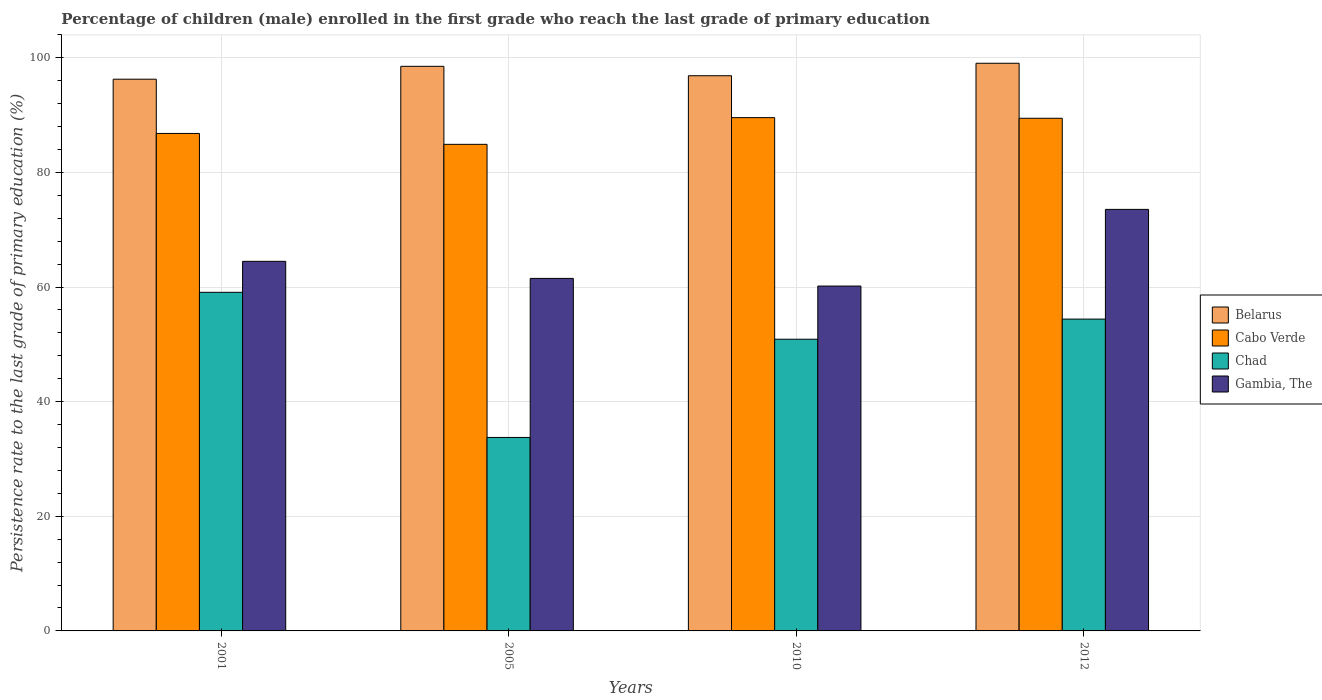How many different coloured bars are there?
Keep it short and to the point. 4. How many bars are there on the 2nd tick from the left?
Your response must be concise. 4. What is the persistence rate of children in Chad in 2005?
Your answer should be very brief. 33.76. Across all years, what is the maximum persistence rate of children in Chad?
Your response must be concise. 59.08. Across all years, what is the minimum persistence rate of children in Cabo Verde?
Provide a succinct answer. 84.91. In which year was the persistence rate of children in Gambia, The minimum?
Provide a succinct answer. 2010. What is the total persistence rate of children in Cabo Verde in the graph?
Make the answer very short. 350.73. What is the difference between the persistence rate of children in Chad in 2005 and that in 2010?
Offer a terse response. -17.14. What is the difference between the persistence rate of children in Chad in 2005 and the persistence rate of children in Cabo Verde in 2012?
Ensure brevity in your answer.  -55.69. What is the average persistence rate of children in Chad per year?
Provide a succinct answer. 49.54. In the year 2001, what is the difference between the persistence rate of children in Chad and persistence rate of children in Cabo Verde?
Provide a short and direct response. -27.72. In how many years, is the persistence rate of children in Gambia, The greater than 36 %?
Your answer should be very brief. 4. What is the ratio of the persistence rate of children in Belarus in 2005 to that in 2010?
Keep it short and to the point. 1.02. Is the persistence rate of children in Chad in 2005 less than that in 2012?
Offer a terse response. Yes. Is the difference between the persistence rate of children in Chad in 2010 and 2012 greater than the difference between the persistence rate of children in Cabo Verde in 2010 and 2012?
Give a very brief answer. No. What is the difference between the highest and the second highest persistence rate of children in Belarus?
Keep it short and to the point. 0.54. What is the difference between the highest and the lowest persistence rate of children in Belarus?
Your response must be concise. 2.78. In how many years, is the persistence rate of children in Gambia, The greater than the average persistence rate of children in Gambia, The taken over all years?
Offer a terse response. 1. Is the sum of the persistence rate of children in Chad in 2010 and 2012 greater than the maximum persistence rate of children in Belarus across all years?
Your response must be concise. Yes. What does the 1st bar from the left in 2001 represents?
Offer a terse response. Belarus. What does the 2nd bar from the right in 2001 represents?
Your answer should be compact. Chad. Is it the case that in every year, the sum of the persistence rate of children in Belarus and persistence rate of children in Cabo Verde is greater than the persistence rate of children in Chad?
Provide a succinct answer. Yes. How many bars are there?
Make the answer very short. 16. How many years are there in the graph?
Your answer should be compact. 4. Does the graph contain any zero values?
Offer a terse response. No. Does the graph contain grids?
Your answer should be very brief. Yes. How many legend labels are there?
Keep it short and to the point. 4. How are the legend labels stacked?
Offer a terse response. Vertical. What is the title of the graph?
Offer a terse response. Percentage of children (male) enrolled in the first grade who reach the last grade of primary education. Does "French Polynesia" appear as one of the legend labels in the graph?
Provide a short and direct response. No. What is the label or title of the X-axis?
Provide a succinct answer. Years. What is the label or title of the Y-axis?
Your answer should be very brief. Persistence rate to the last grade of primary education (%). What is the Persistence rate to the last grade of primary education (%) of Belarus in 2001?
Ensure brevity in your answer.  96.27. What is the Persistence rate to the last grade of primary education (%) of Cabo Verde in 2001?
Make the answer very short. 86.81. What is the Persistence rate to the last grade of primary education (%) of Chad in 2001?
Make the answer very short. 59.08. What is the Persistence rate to the last grade of primary education (%) of Gambia, The in 2001?
Provide a short and direct response. 64.49. What is the Persistence rate to the last grade of primary education (%) in Belarus in 2005?
Give a very brief answer. 98.52. What is the Persistence rate to the last grade of primary education (%) of Cabo Verde in 2005?
Your response must be concise. 84.91. What is the Persistence rate to the last grade of primary education (%) in Chad in 2005?
Your response must be concise. 33.76. What is the Persistence rate to the last grade of primary education (%) in Gambia, The in 2005?
Ensure brevity in your answer.  61.51. What is the Persistence rate to the last grade of primary education (%) of Belarus in 2010?
Ensure brevity in your answer.  96.88. What is the Persistence rate to the last grade of primary education (%) of Cabo Verde in 2010?
Make the answer very short. 89.57. What is the Persistence rate to the last grade of primary education (%) of Chad in 2010?
Your response must be concise. 50.9. What is the Persistence rate to the last grade of primary education (%) in Gambia, The in 2010?
Offer a very short reply. 60.18. What is the Persistence rate to the last grade of primary education (%) of Belarus in 2012?
Offer a very short reply. 99.05. What is the Persistence rate to the last grade of primary education (%) in Cabo Verde in 2012?
Your answer should be compact. 89.45. What is the Persistence rate to the last grade of primary education (%) in Chad in 2012?
Your answer should be very brief. 54.41. What is the Persistence rate to the last grade of primary education (%) in Gambia, The in 2012?
Your answer should be very brief. 73.56. Across all years, what is the maximum Persistence rate to the last grade of primary education (%) in Belarus?
Keep it short and to the point. 99.05. Across all years, what is the maximum Persistence rate to the last grade of primary education (%) in Cabo Verde?
Your response must be concise. 89.57. Across all years, what is the maximum Persistence rate to the last grade of primary education (%) of Chad?
Provide a succinct answer. 59.08. Across all years, what is the maximum Persistence rate to the last grade of primary education (%) of Gambia, The?
Your answer should be very brief. 73.56. Across all years, what is the minimum Persistence rate to the last grade of primary education (%) in Belarus?
Offer a terse response. 96.27. Across all years, what is the minimum Persistence rate to the last grade of primary education (%) of Cabo Verde?
Ensure brevity in your answer.  84.91. Across all years, what is the minimum Persistence rate to the last grade of primary education (%) in Chad?
Provide a succinct answer. 33.76. Across all years, what is the minimum Persistence rate to the last grade of primary education (%) in Gambia, The?
Give a very brief answer. 60.18. What is the total Persistence rate to the last grade of primary education (%) of Belarus in the graph?
Provide a short and direct response. 390.72. What is the total Persistence rate to the last grade of primary education (%) of Cabo Verde in the graph?
Give a very brief answer. 350.73. What is the total Persistence rate to the last grade of primary education (%) in Chad in the graph?
Give a very brief answer. 198.15. What is the total Persistence rate to the last grade of primary education (%) in Gambia, The in the graph?
Your answer should be compact. 259.74. What is the difference between the Persistence rate to the last grade of primary education (%) of Belarus in 2001 and that in 2005?
Your answer should be very brief. -2.25. What is the difference between the Persistence rate to the last grade of primary education (%) in Cabo Verde in 2001 and that in 2005?
Offer a terse response. 1.9. What is the difference between the Persistence rate to the last grade of primary education (%) in Chad in 2001 and that in 2005?
Make the answer very short. 25.32. What is the difference between the Persistence rate to the last grade of primary education (%) in Gambia, The in 2001 and that in 2005?
Provide a succinct answer. 2.98. What is the difference between the Persistence rate to the last grade of primary education (%) of Belarus in 2001 and that in 2010?
Keep it short and to the point. -0.61. What is the difference between the Persistence rate to the last grade of primary education (%) of Cabo Verde in 2001 and that in 2010?
Offer a very short reply. -2.76. What is the difference between the Persistence rate to the last grade of primary education (%) of Chad in 2001 and that in 2010?
Ensure brevity in your answer.  8.19. What is the difference between the Persistence rate to the last grade of primary education (%) in Gambia, The in 2001 and that in 2010?
Provide a succinct answer. 4.31. What is the difference between the Persistence rate to the last grade of primary education (%) in Belarus in 2001 and that in 2012?
Give a very brief answer. -2.78. What is the difference between the Persistence rate to the last grade of primary education (%) in Cabo Verde in 2001 and that in 2012?
Make the answer very short. -2.65. What is the difference between the Persistence rate to the last grade of primary education (%) of Chad in 2001 and that in 2012?
Keep it short and to the point. 4.67. What is the difference between the Persistence rate to the last grade of primary education (%) in Gambia, The in 2001 and that in 2012?
Give a very brief answer. -9.07. What is the difference between the Persistence rate to the last grade of primary education (%) of Belarus in 2005 and that in 2010?
Make the answer very short. 1.64. What is the difference between the Persistence rate to the last grade of primary education (%) of Cabo Verde in 2005 and that in 2010?
Offer a terse response. -4.66. What is the difference between the Persistence rate to the last grade of primary education (%) in Chad in 2005 and that in 2010?
Make the answer very short. -17.14. What is the difference between the Persistence rate to the last grade of primary education (%) in Gambia, The in 2005 and that in 2010?
Your answer should be compact. 1.34. What is the difference between the Persistence rate to the last grade of primary education (%) in Belarus in 2005 and that in 2012?
Provide a short and direct response. -0.54. What is the difference between the Persistence rate to the last grade of primary education (%) of Cabo Verde in 2005 and that in 2012?
Give a very brief answer. -4.55. What is the difference between the Persistence rate to the last grade of primary education (%) of Chad in 2005 and that in 2012?
Provide a short and direct response. -20.65. What is the difference between the Persistence rate to the last grade of primary education (%) of Gambia, The in 2005 and that in 2012?
Offer a terse response. -12.04. What is the difference between the Persistence rate to the last grade of primary education (%) of Belarus in 2010 and that in 2012?
Ensure brevity in your answer.  -2.18. What is the difference between the Persistence rate to the last grade of primary education (%) in Cabo Verde in 2010 and that in 2012?
Provide a succinct answer. 0.11. What is the difference between the Persistence rate to the last grade of primary education (%) in Chad in 2010 and that in 2012?
Ensure brevity in your answer.  -3.51. What is the difference between the Persistence rate to the last grade of primary education (%) of Gambia, The in 2010 and that in 2012?
Your response must be concise. -13.38. What is the difference between the Persistence rate to the last grade of primary education (%) of Belarus in 2001 and the Persistence rate to the last grade of primary education (%) of Cabo Verde in 2005?
Ensure brevity in your answer.  11.37. What is the difference between the Persistence rate to the last grade of primary education (%) of Belarus in 2001 and the Persistence rate to the last grade of primary education (%) of Chad in 2005?
Make the answer very short. 62.51. What is the difference between the Persistence rate to the last grade of primary education (%) of Belarus in 2001 and the Persistence rate to the last grade of primary education (%) of Gambia, The in 2005?
Give a very brief answer. 34.76. What is the difference between the Persistence rate to the last grade of primary education (%) in Cabo Verde in 2001 and the Persistence rate to the last grade of primary education (%) in Chad in 2005?
Keep it short and to the point. 53.04. What is the difference between the Persistence rate to the last grade of primary education (%) of Cabo Verde in 2001 and the Persistence rate to the last grade of primary education (%) of Gambia, The in 2005?
Make the answer very short. 25.29. What is the difference between the Persistence rate to the last grade of primary education (%) in Chad in 2001 and the Persistence rate to the last grade of primary education (%) in Gambia, The in 2005?
Ensure brevity in your answer.  -2.43. What is the difference between the Persistence rate to the last grade of primary education (%) of Belarus in 2001 and the Persistence rate to the last grade of primary education (%) of Cabo Verde in 2010?
Make the answer very short. 6.71. What is the difference between the Persistence rate to the last grade of primary education (%) of Belarus in 2001 and the Persistence rate to the last grade of primary education (%) of Chad in 2010?
Make the answer very short. 45.37. What is the difference between the Persistence rate to the last grade of primary education (%) of Belarus in 2001 and the Persistence rate to the last grade of primary education (%) of Gambia, The in 2010?
Provide a succinct answer. 36.09. What is the difference between the Persistence rate to the last grade of primary education (%) in Cabo Verde in 2001 and the Persistence rate to the last grade of primary education (%) in Chad in 2010?
Provide a succinct answer. 35.91. What is the difference between the Persistence rate to the last grade of primary education (%) in Cabo Verde in 2001 and the Persistence rate to the last grade of primary education (%) in Gambia, The in 2010?
Offer a very short reply. 26.63. What is the difference between the Persistence rate to the last grade of primary education (%) in Chad in 2001 and the Persistence rate to the last grade of primary education (%) in Gambia, The in 2010?
Provide a succinct answer. -1.09. What is the difference between the Persistence rate to the last grade of primary education (%) in Belarus in 2001 and the Persistence rate to the last grade of primary education (%) in Cabo Verde in 2012?
Make the answer very short. 6.82. What is the difference between the Persistence rate to the last grade of primary education (%) in Belarus in 2001 and the Persistence rate to the last grade of primary education (%) in Chad in 2012?
Provide a short and direct response. 41.86. What is the difference between the Persistence rate to the last grade of primary education (%) in Belarus in 2001 and the Persistence rate to the last grade of primary education (%) in Gambia, The in 2012?
Give a very brief answer. 22.72. What is the difference between the Persistence rate to the last grade of primary education (%) in Cabo Verde in 2001 and the Persistence rate to the last grade of primary education (%) in Chad in 2012?
Ensure brevity in your answer.  32.4. What is the difference between the Persistence rate to the last grade of primary education (%) in Cabo Verde in 2001 and the Persistence rate to the last grade of primary education (%) in Gambia, The in 2012?
Provide a short and direct response. 13.25. What is the difference between the Persistence rate to the last grade of primary education (%) of Chad in 2001 and the Persistence rate to the last grade of primary education (%) of Gambia, The in 2012?
Ensure brevity in your answer.  -14.47. What is the difference between the Persistence rate to the last grade of primary education (%) of Belarus in 2005 and the Persistence rate to the last grade of primary education (%) of Cabo Verde in 2010?
Make the answer very short. 8.95. What is the difference between the Persistence rate to the last grade of primary education (%) in Belarus in 2005 and the Persistence rate to the last grade of primary education (%) in Chad in 2010?
Give a very brief answer. 47.62. What is the difference between the Persistence rate to the last grade of primary education (%) of Belarus in 2005 and the Persistence rate to the last grade of primary education (%) of Gambia, The in 2010?
Make the answer very short. 38.34. What is the difference between the Persistence rate to the last grade of primary education (%) of Cabo Verde in 2005 and the Persistence rate to the last grade of primary education (%) of Chad in 2010?
Ensure brevity in your answer.  34.01. What is the difference between the Persistence rate to the last grade of primary education (%) in Cabo Verde in 2005 and the Persistence rate to the last grade of primary education (%) in Gambia, The in 2010?
Offer a very short reply. 24.73. What is the difference between the Persistence rate to the last grade of primary education (%) in Chad in 2005 and the Persistence rate to the last grade of primary education (%) in Gambia, The in 2010?
Your answer should be very brief. -26.42. What is the difference between the Persistence rate to the last grade of primary education (%) of Belarus in 2005 and the Persistence rate to the last grade of primary education (%) of Cabo Verde in 2012?
Your response must be concise. 9.07. What is the difference between the Persistence rate to the last grade of primary education (%) in Belarus in 2005 and the Persistence rate to the last grade of primary education (%) in Chad in 2012?
Offer a very short reply. 44.11. What is the difference between the Persistence rate to the last grade of primary education (%) of Belarus in 2005 and the Persistence rate to the last grade of primary education (%) of Gambia, The in 2012?
Offer a very short reply. 24.96. What is the difference between the Persistence rate to the last grade of primary education (%) of Cabo Verde in 2005 and the Persistence rate to the last grade of primary education (%) of Chad in 2012?
Provide a short and direct response. 30.5. What is the difference between the Persistence rate to the last grade of primary education (%) of Cabo Verde in 2005 and the Persistence rate to the last grade of primary education (%) of Gambia, The in 2012?
Keep it short and to the point. 11.35. What is the difference between the Persistence rate to the last grade of primary education (%) in Chad in 2005 and the Persistence rate to the last grade of primary education (%) in Gambia, The in 2012?
Offer a terse response. -39.8. What is the difference between the Persistence rate to the last grade of primary education (%) of Belarus in 2010 and the Persistence rate to the last grade of primary education (%) of Cabo Verde in 2012?
Give a very brief answer. 7.43. What is the difference between the Persistence rate to the last grade of primary education (%) of Belarus in 2010 and the Persistence rate to the last grade of primary education (%) of Chad in 2012?
Provide a short and direct response. 42.47. What is the difference between the Persistence rate to the last grade of primary education (%) of Belarus in 2010 and the Persistence rate to the last grade of primary education (%) of Gambia, The in 2012?
Make the answer very short. 23.32. What is the difference between the Persistence rate to the last grade of primary education (%) of Cabo Verde in 2010 and the Persistence rate to the last grade of primary education (%) of Chad in 2012?
Offer a very short reply. 35.16. What is the difference between the Persistence rate to the last grade of primary education (%) of Cabo Verde in 2010 and the Persistence rate to the last grade of primary education (%) of Gambia, The in 2012?
Your answer should be compact. 16.01. What is the difference between the Persistence rate to the last grade of primary education (%) in Chad in 2010 and the Persistence rate to the last grade of primary education (%) in Gambia, The in 2012?
Provide a succinct answer. -22.66. What is the average Persistence rate to the last grade of primary education (%) of Belarus per year?
Make the answer very short. 97.68. What is the average Persistence rate to the last grade of primary education (%) of Cabo Verde per year?
Keep it short and to the point. 87.68. What is the average Persistence rate to the last grade of primary education (%) of Chad per year?
Keep it short and to the point. 49.54. What is the average Persistence rate to the last grade of primary education (%) of Gambia, The per year?
Ensure brevity in your answer.  64.93. In the year 2001, what is the difference between the Persistence rate to the last grade of primary education (%) of Belarus and Persistence rate to the last grade of primary education (%) of Cabo Verde?
Your answer should be very brief. 9.47. In the year 2001, what is the difference between the Persistence rate to the last grade of primary education (%) in Belarus and Persistence rate to the last grade of primary education (%) in Chad?
Offer a very short reply. 37.19. In the year 2001, what is the difference between the Persistence rate to the last grade of primary education (%) of Belarus and Persistence rate to the last grade of primary education (%) of Gambia, The?
Provide a short and direct response. 31.78. In the year 2001, what is the difference between the Persistence rate to the last grade of primary education (%) in Cabo Verde and Persistence rate to the last grade of primary education (%) in Chad?
Your answer should be very brief. 27.72. In the year 2001, what is the difference between the Persistence rate to the last grade of primary education (%) of Cabo Verde and Persistence rate to the last grade of primary education (%) of Gambia, The?
Offer a very short reply. 22.31. In the year 2001, what is the difference between the Persistence rate to the last grade of primary education (%) in Chad and Persistence rate to the last grade of primary education (%) in Gambia, The?
Make the answer very short. -5.41. In the year 2005, what is the difference between the Persistence rate to the last grade of primary education (%) in Belarus and Persistence rate to the last grade of primary education (%) in Cabo Verde?
Keep it short and to the point. 13.61. In the year 2005, what is the difference between the Persistence rate to the last grade of primary education (%) of Belarus and Persistence rate to the last grade of primary education (%) of Chad?
Your response must be concise. 64.76. In the year 2005, what is the difference between the Persistence rate to the last grade of primary education (%) of Belarus and Persistence rate to the last grade of primary education (%) of Gambia, The?
Your answer should be very brief. 37. In the year 2005, what is the difference between the Persistence rate to the last grade of primary education (%) in Cabo Verde and Persistence rate to the last grade of primary education (%) in Chad?
Keep it short and to the point. 51.15. In the year 2005, what is the difference between the Persistence rate to the last grade of primary education (%) in Cabo Verde and Persistence rate to the last grade of primary education (%) in Gambia, The?
Provide a short and direct response. 23.39. In the year 2005, what is the difference between the Persistence rate to the last grade of primary education (%) of Chad and Persistence rate to the last grade of primary education (%) of Gambia, The?
Offer a terse response. -27.75. In the year 2010, what is the difference between the Persistence rate to the last grade of primary education (%) in Belarus and Persistence rate to the last grade of primary education (%) in Cabo Verde?
Ensure brevity in your answer.  7.31. In the year 2010, what is the difference between the Persistence rate to the last grade of primary education (%) of Belarus and Persistence rate to the last grade of primary education (%) of Chad?
Offer a very short reply. 45.98. In the year 2010, what is the difference between the Persistence rate to the last grade of primary education (%) in Belarus and Persistence rate to the last grade of primary education (%) in Gambia, The?
Offer a very short reply. 36.7. In the year 2010, what is the difference between the Persistence rate to the last grade of primary education (%) of Cabo Verde and Persistence rate to the last grade of primary education (%) of Chad?
Offer a terse response. 38.67. In the year 2010, what is the difference between the Persistence rate to the last grade of primary education (%) of Cabo Verde and Persistence rate to the last grade of primary education (%) of Gambia, The?
Your response must be concise. 29.39. In the year 2010, what is the difference between the Persistence rate to the last grade of primary education (%) in Chad and Persistence rate to the last grade of primary education (%) in Gambia, The?
Your response must be concise. -9.28. In the year 2012, what is the difference between the Persistence rate to the last grade of primary education (%) of Belarus and Persistence rate to the last grade of primary education (%) of Cabo Verde?
Provide a short and direct response. 9.6. In the year 2012, what is the difference between the Persistence rate to the last grade of primary education (%) of Belarus and Persistence rate to the last grade of primary education (%) of Chad?
Make the answer very short. 44.64. In the year 2012, what is the difference between the Persistence rate to the last grade of primary education (%) of Belarus and Persistence rate to the last grade of primary education (%) of Gambia, The?
Offer a terse response. 25.5. In the year 2012, what is the difference between the Persistence rate to the last grade of primary education (%) in Cabo Verde and Persistence rate to the last grade of primary education (%) in Chad?
Your answer should be very brief. 35.04. In the year 2012, what is the difference between the Persistence rate to the last grade of primary education (%) of Cabo Verde and Persistence rate to the last grade of primary education (%) of Gambia, The?
Offer a very short reply. 15.9. In the year 2012, what is the difference between the Persistence rate to the last grade of primary education (%) in Chad and Persistence rate to the last grade of primary education (%) in Gambia, The?
Give a very brief answer. -19.15. What is the ratio of the Persistence rate to the last grade of primary education (%) of Belarus in 2001 to that in 2005?
Your response must be concise. 0.98. What is the ratio of the Persistence rate to the last grade of primary education (%) of Cabo Verde in 2001 to that in 2005?
Provide a succinct answer. 1.02. What is the ratio of the Persistence rate to the last grade of primary education (%) of Chad in 2001 to that in 2005?
Your answer should be very brief. 1.75. What is the ratio of the Persistence rate to the last grade of primary education (%) in Gambia, The in 2001 to that in 2005?
Your response must be concise. 1.05. What is the ratio of the Persistence rate to the last grade of primary education (%) of Belarus in 2001 to that in 2010?
Your response must be concise. 0.99. What is the ratio of the Persistence rate to the last grade of primary education (%) in Cabo Verde in 2001 to that in 2010?
Offer a terse response. 0.97. What is the ratio of the Persistence rate to the last grade of primary education (%) in Chad in 2001 to that in 2010?
Keep it short and to the point. 1.16. What is the ratio of the Persistence rate to the last grade of primary education (%) in Gambia, The in 2001 to that in 2010?
Offer a very short reply. 1.07. What is the ratio of the Persistence rate to the last grade of primary education (%) of Belarus in 2001 to that in 2012?
Give a very brief answer. 0.97. What is the ratio of the Persistence rate to the last grade of primary education (%) in Cabo Verde in 2001 to that in 2012?
Provide a succinct answer. 0.97. What is the ratio of the Persistence rate to the last grade of primary education (%) of Chad in 2001 to that in 2012?
Give a very brief answer. 1.09. What is the ratio of the Persistence rate to the last grade of primary education (%) of Gambia, The in 2001 to that in 2012?
Your response must be concise. 0.88. What is the ratio of the Persistence rate to the last grade of primary education (%) in Belarus in 2005 to that in 2010?
Your response must be concise. 1.02. What is the ratio of the Persistence rate to the last grade of primary education (%) of Cabo Verde in 2005 to that in 2010?
Provide a succinct answer. 0.95. What is the ratio of the Persistence rate to the last grade of primary education (%) in Chad in 2005 to that in 2010?
Make the answer very short. 0.66. What is the ratio of the Persistence rate to the last grade of primary education (%) in Gambia, The in 2005 to that in 2010?
Your response must be concise. 1.02. What is the ratio of the Persistence rate to the last grade of primary education (%) of Cabo Verde in 2005 to that in 2012?
Offer a terse response. 0.95. What is the ratio of the Persistence rate to the last grade of primary education (%) of Chad in 2005 to that in 2012?
Your answer should be compact. 0.62. What is the ratio of the Persistence rate to the last grade of primary education (%) of Gambia, The in 2005 to that in 2012?
Provide a succinct answer. 0.84. What is the ratio of the Persistence rate to the last grade of primary education (%) in Belarus in 2010 to that in 2012?
Give a very brief answer. 0.98. What is the ratio of the Persistence rate to the last grade of primary education (%) of Chad in 2010 to that in 2012?
Your answer should be very brief. 0.94. What is the ratio of the Persistence rate to the last grade of primary education (%) of Gambia, The in 2010 to that in 2012?
Ensure brevity in your answer.  0.82. What is the difference between the highest and the second highest Persistence rate to the last grade of primary education (%) in Belarus?
Make the answer very short. 0.54. What is the difference between the highest and the second highest Persistence rate to the last grade of primary education (%) in Cabo Verde?
Offer a terse response. 0.11. What is the difference between the highest and the second highest Persistence rate to the last grade of primary education (%) of Chad?
Your response must be concise. 4.67. What is the difference between the highest and the second highest Persistence rate to the last grade of primary education (%) in Gambia, The?
Make the answer very short. 9.07. What is the difference between the highest and the lowest Persistence rate to the last grade of primary education (%) of Belarus?
Provide a short and direct response. 2.78. What is the difference between the highest and the lowest Persistence rate to the last grade of primary education (%) of Cabo Verde?
Ensure brevity in your answer.  4.66. What is the difference between the highest and the lowest Persistence rate to the last grade of primary education (%) of Chad?
Your response must be concise. 25.32. What is the difference between the highest and the lowest Persistence rate to the last grade of primary education (%) of Gambia, The?
Your answer should be compact. 13.38. 